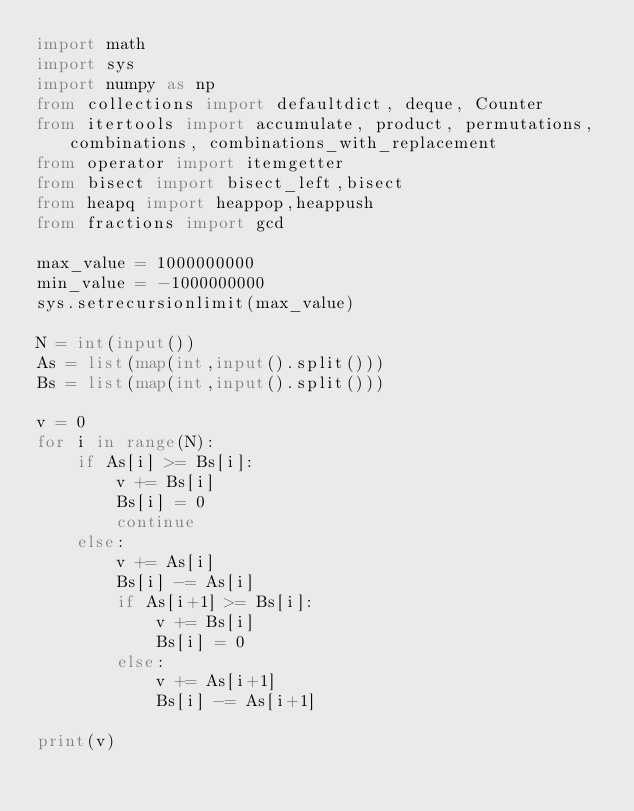Convert code to text. <code><loc_0><loc_0><loc_500><loc_500><_Python_>import math
import sys
import numpy as np
from collections import defaultdict, deque, Counter 
from itertools import accumulate, product, permutations,combinations, combinations_with_replacement
from operator import itemgetter
from bisect import bisect_left,bisect
from heapq import heappop,heappush
from fractions import gcd

max_value = 1000000000
min_value = -1000000000
sys.setrecursionlimit(max_value)

N = int(input())
As = list(map(int,input().split()))
Bs = list(map(int,input().split()))

v = 0
for i in range(N):
    if As[i] >= Bs[i]:
        v += Bs[i]
        Bs[i] = 0
        continue
    else:
        v += As[i]
        Bs[i] -= As[i]
        if As[i+1] >= Bs[i]:
            v += Bs[i]
            Bs[i] = 0
        else:
            v += As[i+1]
            Bs[i] -= As[i+1]
        
print(v)
</code> 